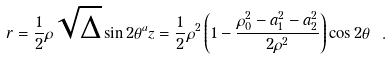<formula> <loc_0><loc_0><loc_500><loc_500>r = \frac { 1 } { 2 } \rho \sqrt { \Delta } \sin 2 \theta ^ { a } z = \frac { 1 } { 2 } \rho ^ { 2 } \left ( 1 - \frac { \rho _ { 0 } ^ { 2 } - a _ { 1 } ^ { 2 } - a _ { 2 } ^ { 2 } } { 2 \rho ^ { 2 } } \right ) \cos 2 \theta \ .</formula> 